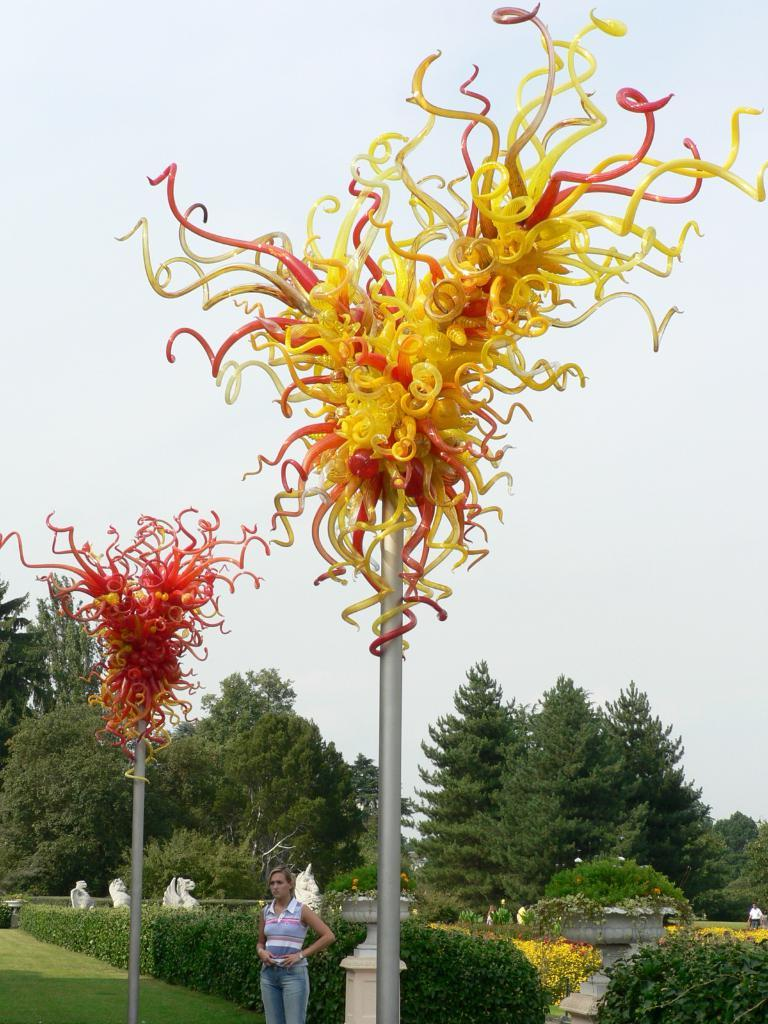Who is present in the image? There is a woman in the image. What is the woman standing between? The woman is standing between decorative poles. What type of natural elements can be seen in the image? There are trees and plants visible in the image. What type of artistic elements can be seen in the image? There are sculptures in the image. What type of blood is visible on the sculptures in the image? There is no blood visible on the sculptures in the image. 